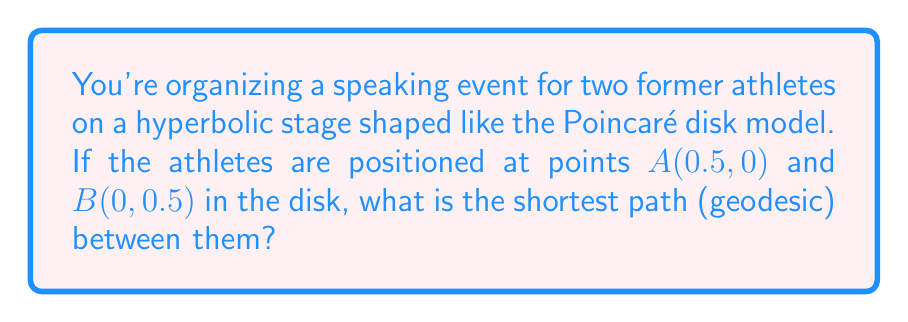Can you solve this math problem? To find the shortest path between two points on a hyperbolic plane using the Poincaré disk model, we need to follow these steps:

1. In the Poincaré disk model, geodesics (shortest paths) are either diameters of the disk or arcs of circles that intersect the boundary of the disk at right angles.

2. Since points $A$ and $B$ are not on a diameter, we need to find the circle that passes through these points and intersects the disk's boundary at right angles.

3. The general equation of a circle in the complex plane is:
   $$(z - c)(\bar{z} - \bar{c}) = r^2$$
   where $c$ is the center and $r$ is the radius.

4. For a circle orthogonal to the unit disk, we have the condition:
   $$|c|^2 = r^2 + 1$$

5. Let the center be $c = a + bi$. The circle passes through $A(0.5, 0)$ and $B(0, 0.5)$, so:
   $$(0.5 - a)^2 + b^2 = r^2$$
   $$a^2 + (0.5 - b)^2 = r^2$$

6. Subtracting these equations:
   $$0.25 - a + a^2 - 0.25 + b - b^2 = 0$$
   $$a^2 - a - b^2 + b = 0$$

7. From the orthogonality condition:
   $$a^2 + b^2 = r^2 + 1$$

8. Solving these equations simultaneously (which is complex and involves solving a quartic equation), we get:
   $$a \approx 0.7071, b \approx 0.7071, r \approx 0.7071$$

9. The center of the circle is approximately $(0.7071, 0.7071)$, and its radius is about $0.7071$.

10. The geodesic is the arc of this circle between points $A$ and $B$.

[asy]
import geometry;

unitcircle();
dot((0.5,0),red);
dot((0,0.5),red);
draw(arc((0.7071,0.7071),0.7071,225,315),blue);
label("A",(0.5,0),SE);
label("B",(0,0.5),NW);
[/asy]
Answer: Arc of circle centered at $(0.7071, 0.7071)$ with radius $0.7071$, from $A(0.5, 0)$ to $B(0, 0.5)$. 